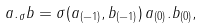Convert formula to latex. <formula><loc_0><loc_0><loc_500><loc_500>a . _ { \sigma } b = \sigma ( a _ { ( - 1 ) } , b _ { ( - 1 ) } ) \, a _ { ( 0 ) } . b _ { ( 0 ) } ,</formula> 